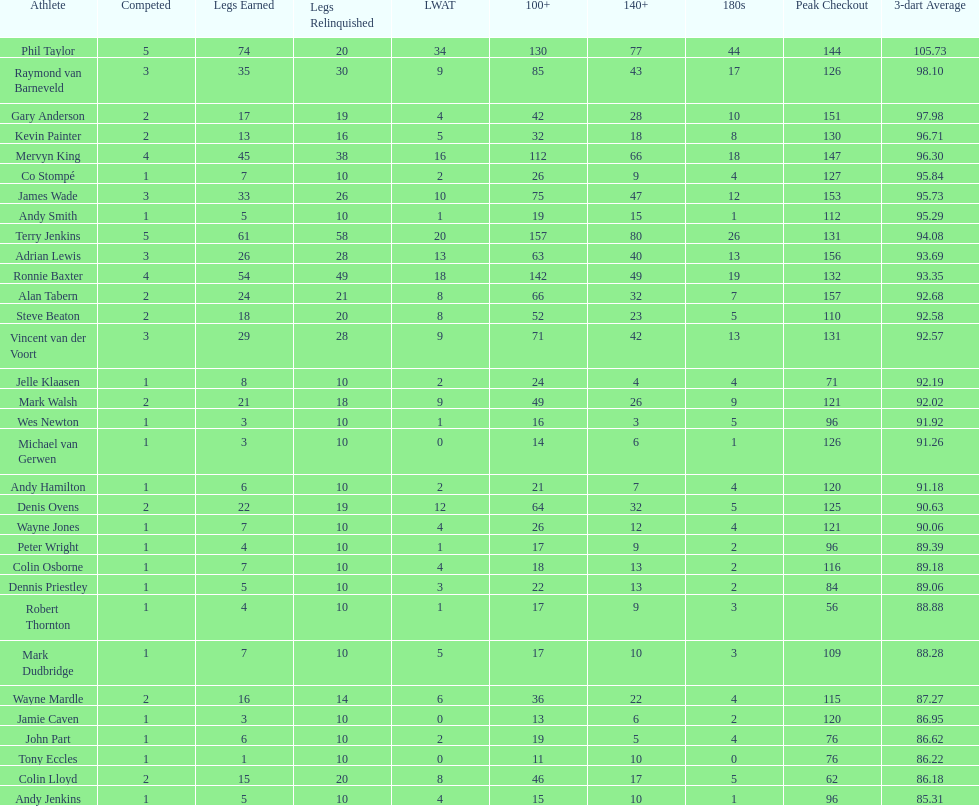Parse the table in full. {'header': ['Athlete', 'Competed', 'Legs Earned', 'Legs Relinquished', 'LWAT', '100+', '140+', '180s', 'Peak Checkout', '3-dart Average'], 'rows': [['Phil Taylor', '5', '74', '20', '34', '130', '77', '44', '144', '105.73'], ['Raymond van Barneveld', '3', '35', '30', '9', '85', '43', '17', '126', '98.10'], ['Gary Anderson', '2', '17', '19', '4', '42', '28', '10', '151', '97.98'], ['Kevin Painter', '2', '13', '16', '5', '32', '18', '8', '130', '96.71'], ['Mervyn King', '4', '45', '38', '16', '112', '66', '18', '147', '96.30'], ['Co Stompé', '1', '7', '10', '2', '26', '9', '4', '127', '95.84'], ['James Wade', '3', '33', '26', '10', '75', '47', '12', '153', '95.73'], ['Andy Smith', '1', '5', '10', '1', '19', '15', '1', '112', '95.29'], ['Terry Jenkins', '5', '61', '58', '20', '157', '80', '26', '131', '94.08'], ['Adrian Lewis', '3', '26', '28', '13', '63', '40', '13', '156', '93.69'], ['Ronnie Baxter', '4', '54', '49', '18', '142', '49', '19', '132', '93.35'], ['Alan Tabern', '2', '24', '21', '8', '66', '32', '7', '157', '92.68'], ['Steve Beaton', '2', '18', '20', '8', '52', '23', '5', '110', '92.58'], ['Vincent van der Voort', '3', '29', '28', '9', '71', '42', '13', '131', '92.57'], ['Jelle Klaasen', '1', '8', '10', '2', '24', '4', '4', '71', '92.19'], ['Mark Walsh', '2', '21', '18', '9', '49', '26', '9', '121', '92.02'], ['Wes Newton', '1', '3', '10', '1', '16', '3', '5', '96', '91.92'], ['Michael van Gerwen', '1', '3', '10', '0', '14', '6', '1', '126', '91.26'], ['Andy Hamilton', '1', '6', '10', '2', '21', '7', '4', '120', '91.18'], ['Denis Ovens', '2', '22', '19', '12', '64', '32', '5', '125', '90.63'], ['Wayne Jones', '1', '7', '10', '4', '26', '12', '4', '121', '90.06'], ['Peter Wright', '1', '4', '10', '1', '17', '9', '2', '96', '89.39'], ['Colin Osborne', '1', '7', '10', '4', '18', '13', '2', '116', '89.18'], ['Dennis Priestley', '1', '5', '10', '3', '22', '13', '2', '84', '89.06'], ['Robert Thornton', '1', '4', '10', '1', '17', '9', '3', '56', '88.88'], ['Mark Dudbridge', '1', '7', '10', '5', '17', '10', '3', '109', '88.28'], ['Wayne Mardle', '2', '16', '14', '6', '36', '22', '4', '115', '87.27'], ['Jamie Caven', '1', '3', '10', '0', '13', '6', '2', '120', '86.95'], ['John Part', '1', '6', '10', '2', '19', '5', '4', '76', '86.62'], ['Tony Eccles', '1', '1', '10', '0', '11', '10', '0', '76', '86.22'], ['Colin Lloyd', '2', '15', '20', '8', '46', '17', '5', '62', '86.18'], ['Andy Jenkins', '1', '5', '10', '4', '15', '10', '1', '96', '85.31']]} Which player has his high checkout as 116? Colin Osborne. 